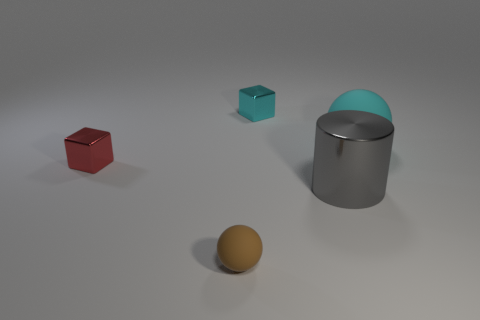What number of other things are the same size as the red metallic thing?
Give a very brief answer. 2. Does the block that is to the right of the brown object have the same material as the big cylinder in front of the red shiny cube?
Keep it short and to the point. Yes. There is a metal cylinder that is the same size as the cyan sphere; what color is it?
Your response must be concise. Gray. Are there any other things that are the same color as the large cylinder?
Make the answer very short. No. What size is the metallic block that is in front of the small thing that is on the right side of the tiny thing in front of the gray object?
Offer a very short reply. Small. The shiny thing that is left of the large gray object and right of the brown sphere is what color?
Give a very brief answer. Cyan. What size is the sphere behind the red thing?
Keep it short and to the point. Large. What number of other balls have the same material as the big ball?
Provide a short and direct response. 1. There is a tiny object that is the same color as the big matte object; what shape is it?
Your response must be concise. Cube. There is a tiny thing left of the small brown matte ball; does it have the same shape as the gray thing?
Your answer should be very brief. No. 